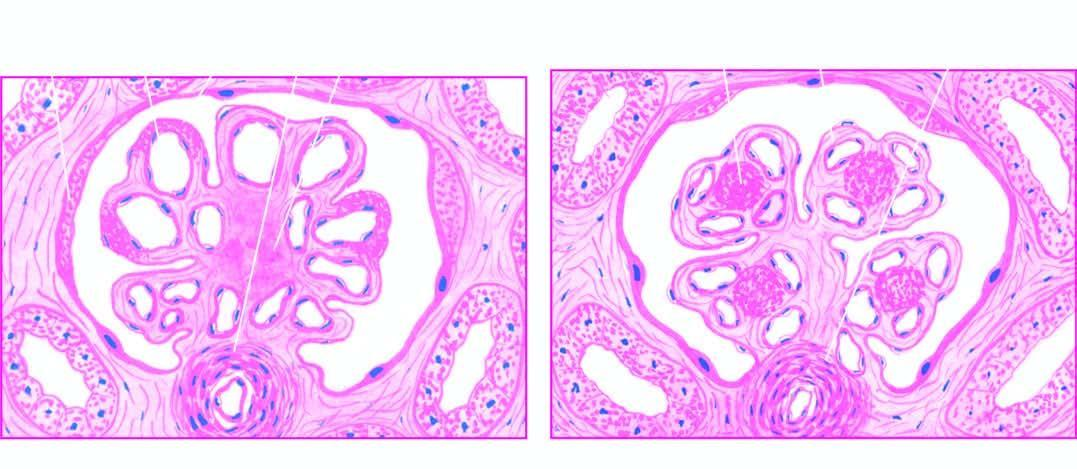re the sectioned surface of the lung parenchyma one or more hyaline nodules within the lobules of glomeruli, surrounded peripherally by glomerular capillaries with thickened walls?
Answer the question using a single word or phrase. No 